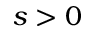<formula> <loc_0><loc_0><loc_500><loc_500>s > 0</formula> 